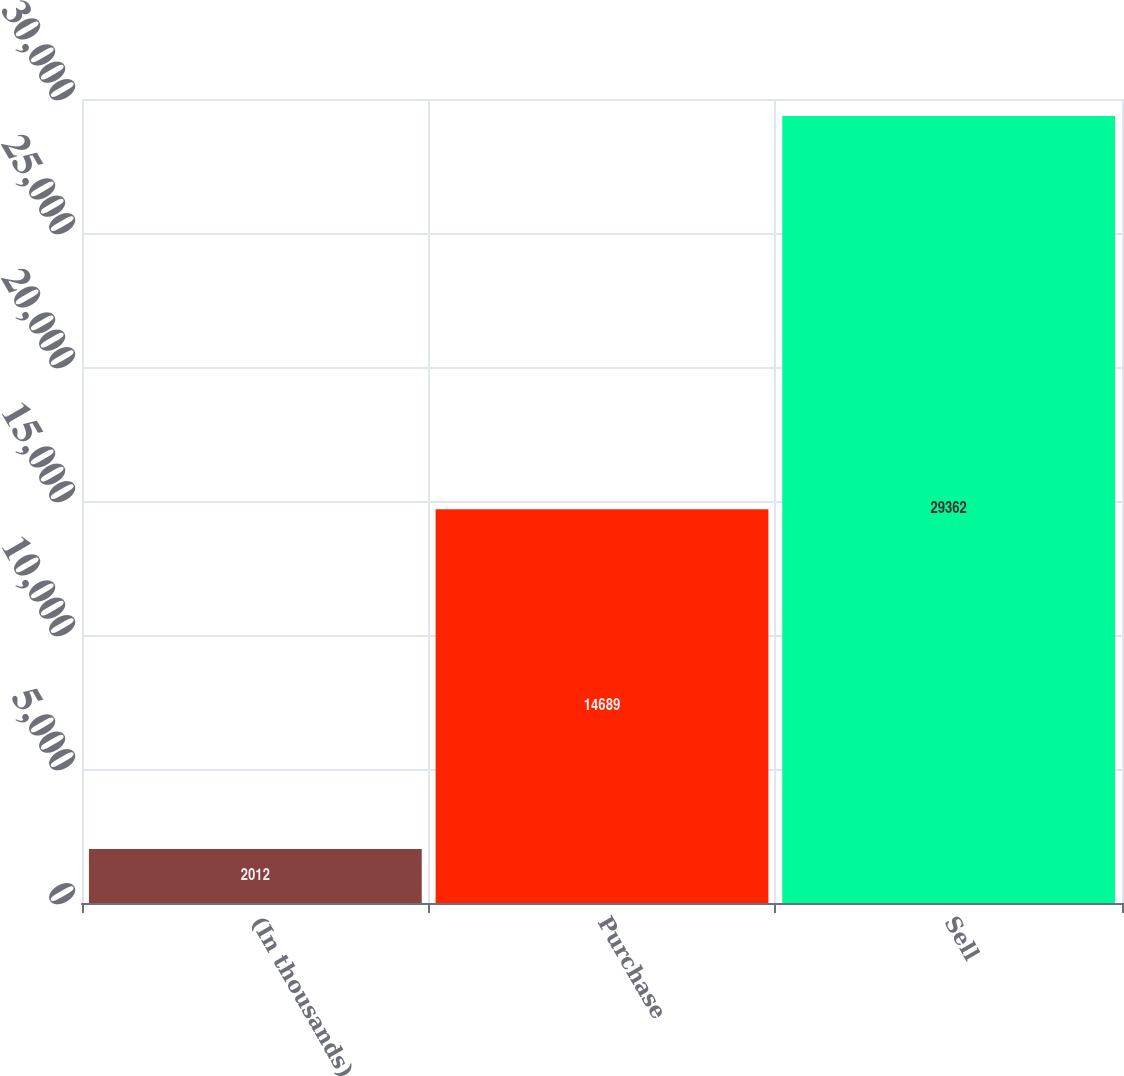<chart> <loc_0><loc_0><loc_500><loc_500><bar_chart><fcel>(In thousands)<fcel>Purchase<fcel>Sell<nl><fcel>2012<fcel>14689<fcel>29362<nl></chart> 